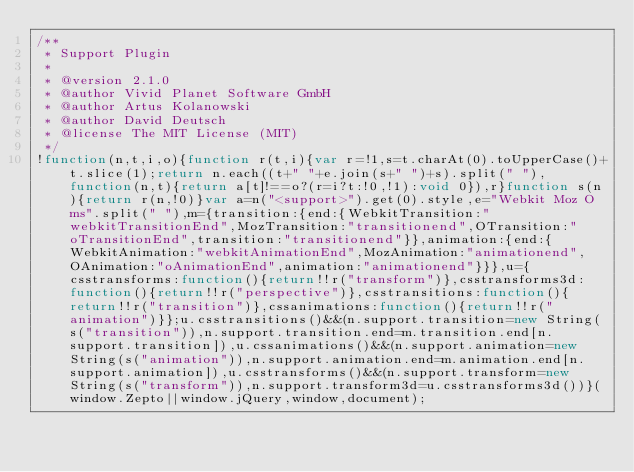Convert code to text. <code><loc_0><loc_0><loc_500><loc_500><_JavaScript_>/**
 * Support Plugin
 *
 * @version 2.1.0
 * @author Vivid Planet Software GmbH
 * @author Artus Kolanowski
 * @author David Deutsch
 * @license The MIT License (MIT)
 */
!function(n,t,i,o){function r(t,i){var r=!1,s=t.charAt(0).toUpperCase()+t.slice(1);return n.each((t+" "+e.join(s+" ")+s).split(" "),function(n,t){return a[t]!==o?(r=i?t:!0,!1):void 0}),r}function s(n){return r(n,!0)}var a=n("<support>").get(0).style,e="Webkit Moz O ms".split(" "),m={transition:{end:{WebkitTransition:"webkitTransitionEnd",MozTransition:"transitionend",OTransition:"oTransitionEnd",transition:"transitionend"}},animation:{end:{WebkitAnimation:"webkitAnimationEnd",MozAnimation:"animationend",OAnimation:"oAnimationEnd",animation:"animationend"}}},u={csstransforms:function(){return!!r("transform")},csstransforms3d:function(){return!!r("perspective")},csstransitions:function(){return!!r("transition")},cssanimations:function(){return!!r("animation")}};u.csstransitions()&&(n.support.transition=new String(s("transition")),n.support.transition.end=m.transition.end[n.support.transition]),u.cssanimations()&&(n.support.animation=new String(s("animation")),n.support.animation.end=m.animation.end[n.support.animation]),u.csstransforms()&&(n.support.transform=new String(s("transform")),n.support.transform3d=u.csstransforms3d())}(window.Zepto||window.jQuery,window,document);</code> 